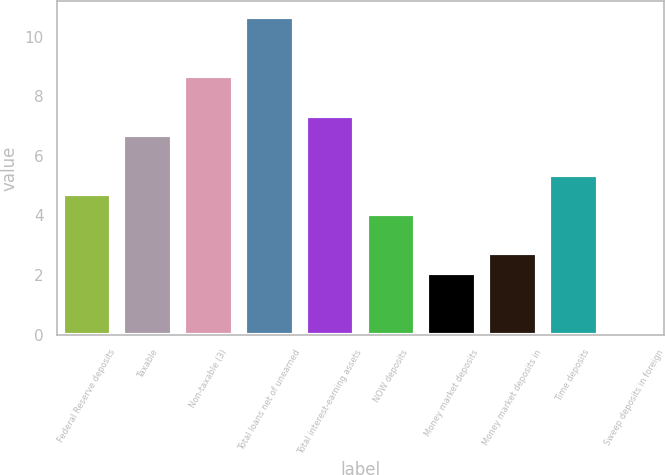Convert chart. <chart><loc_0><loc_0><loc_500><loc_500><bar_chart><fcel>Federal Reserve deposits<fcel>Taxable<fcel>Non-taxable (3)<fcel>Total loans net of unearned<fcel>Total interest-earning assets<fcel>NOW deposits<fcel>Money market deposits<fcel>Money market deposits in<fcel>Time deposits<fcel>Sweep deposits in foreign<nl><fcel>4.71<fcel>6.69<fcel>8.67<fcel>10.65<fcel>7.35<fcel>4.05<fcel>2.07<fcel>2.73<fcel>5.37<fcel>0.09<nl></chart> 